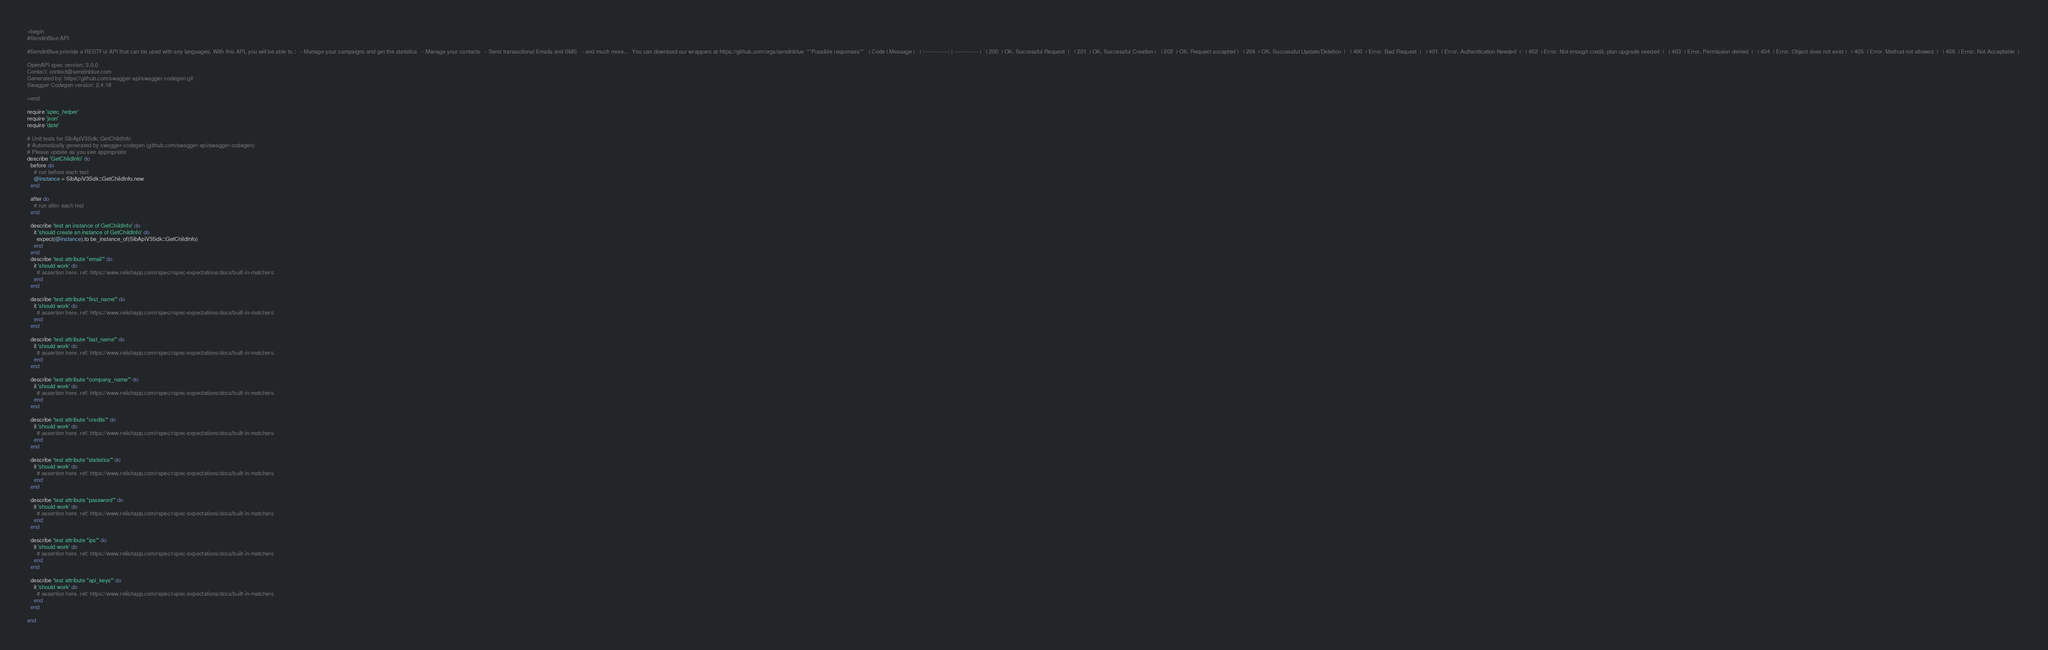<code> <loc_0><loc_0><loc_500><loc_500><_Ruby_>=begin
#SendinBlue API

#SendinBlue provide a RESTFul API that can be used with any languages. With this API, you will be able to :   - Manage your campaigns and get the statistics   - Manage your contacts   - Send transactional Emails and SMS   - and much more...  You can download our wrappers at https://github.com/orgs/sendinblue  **Possible responses**   | Code | Message |   | :-------------: | ------------- |   | 200  | OK. Successful Request  |   | 201  | OK. Successful Creation |   | 202  | OK. Request accepted |   | 204  | OK. Successful Update/Deletion  |   | 400  | Error. Bad Request  |   | 401  | Error. Authentication Needed  |   | 402  | Error. Not enough credit, plan upgrade needed  |   | 403  | Error. Permission denied  |   | 404  | Error. Object does not exist |   | 405  | Error. Method not allowed  |   | 406  | Error. Not Acceptable  | 

OpenAPI spec version: 3.0.0
Contact: contact@sendinblue.com
Generated by: https://github.com/swagger-api/swagger-codegen.git
Swagger Codegen version: 2.4.18

=end

require 'spec_helper'
require 'json'
require 'date'

# Unit tests for SibApiV3Sdk::GetChildInfo
# Automatically generated by swagger-codegen (github.com/swagger-api/swagger-codegen)
# Please update as you see appropriate
describe 'GetChildInfo' do
  before do
    # run before each test
    @instance = SibApiV3Sdk::GetChildInfo.new
  end

  after do
    # run after each test
  end

  describe 'test an instance of GetChildInfo' do
    it 'should create an instance of GetChildInfo' do
      expect(@instance).to be_instance_of(SibApiV3Sdk::GetChildInfo)
    end
  end
  describe 'test attribute "email"' do
    it 'should work' do
      # assertion here. ref: https://www.relishapp.com/rspec/rspec-expectations/docs/built-in-matchers
    end
  end

  describe 'test attribute "first_name"' do
    it 'should work' do
      # assertion here. ref: https://www.relishapp.com/rspec/rspec-expectations/docs/built-in-matchers
    end
  end

  describe 'test attribute "last_name"' do
    it 'should work' do
      # assertion here. ref: https://www.relishapp.com/rspec/rspec-expectations/docs/built-in-matchers
    end
  end

  describe 'test attribute "company_name"' do
    it 'should work' do
      # assertion here. ref: https://www.relishapp.com/rspec/rspec-expectations/docs/built-in-matchers
    end
  end

  describe 'test attribute "credits"' do
    it 'should work' do
      # assertion here. ref: https://www.relishapp.com/rspec/rspec-expectations/docs/built-in-matchers
    end
  end

  describe 'test attribute "statistics"' do
    it 'should work' do
      # assertion here. ref: https://www.relishapp.com/rspec/rspec-expectations/docs/built-in-matchers
    end
  end

  describe 'test attribute "password"' do
    it 'should work' do
      # assertion here. ref: https://www.relishapp.com/rspec/rspec-expectations/docs/built-in-matchers
    end
  end

  describe 'test attribute "ips"' do
    it 'should work' do
      # assertion here. ref: https://www.relishapp.com/rspec/rspec-expectations/docs/built-in-matchers
    end
  end

  describe 'test attribute "api_keys"' do
    it 'should work' do
      # assertion here. ref: https://www.relishapp.com/rspec/rspec-expectations/docs/built-in-matchers
    end
  end

end
</code> 